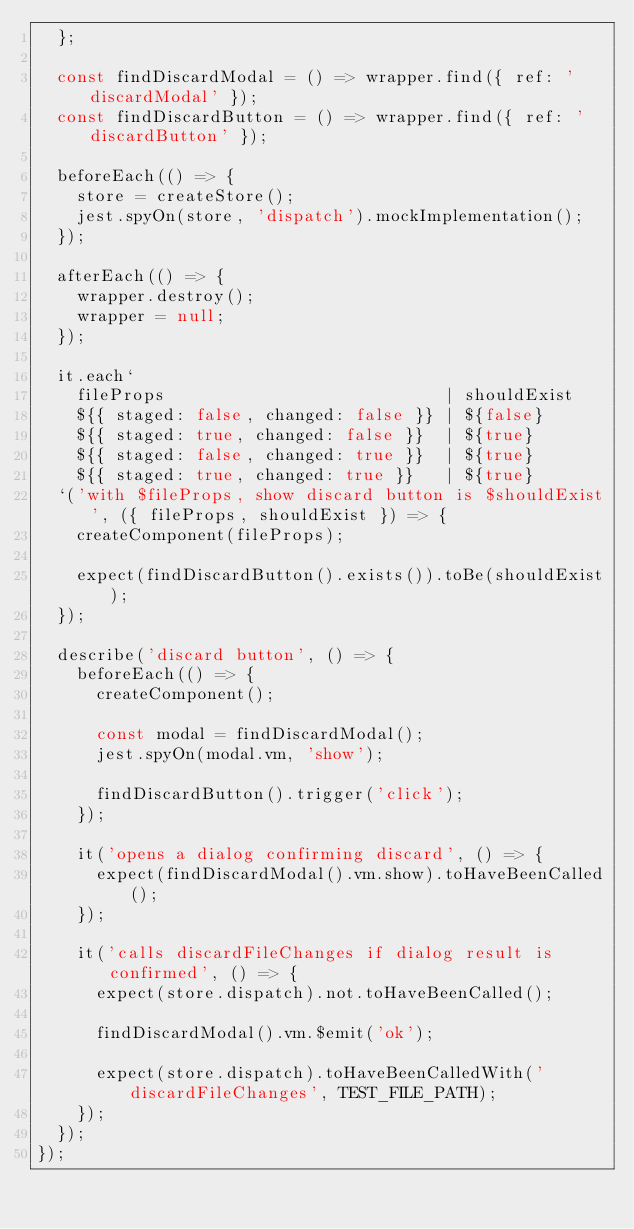Convert code to text. <code><loc_0><loc_0><loc_500><loc_500><_JavaScript_>  };

  const findDiscardModal = () => wrapper.find({ ref: 'discardModal' });
  const findDiscardButton = () => wrapper.find({ ref: 'discardButton' });

  beforeEach(() => {
    store = createStore();
    jest.spyOn(store, 'dispatch').mockImplementation();
  });

  afterEach(() => {
    wrapper.destroy();
    wrapper = null;
  });

  it.each`
    fileProps                            | shouldExist
    ${{ staged: false, changed: false }} | ${false}
    ${{ staged: true, changed: false }}  | ${true}
    ${{ staged: false, changed: true }}  | ${true}
    ${{ staged: true, changed: true }}   | ${true}
  `('with $fileProps, show discard button is $shouldExist', ({ fileProps, shouldExist }) => {
    createComponent(fileProps);

    expect(findDiscardButton().exists()).toBe(shouldExist);
  });

  describe('discard button', () => {
    beforeEach(() => {
      createComponent();

      const modal = findDiscardModal();
      jest.spyOn(modal.vm, 'show');

      findDiscardButton().trigger('click');
    });

    it('opens a dialog confirming discard', () => {
      expect(findDiscardModal().vm.show).toHaveBeenCalled();
    });

    it('calls discardFileChanges if dialog result is confirmed', () => {
      expect(store.dispatch).not.toHaveBeenCalled();

      findDiscardModal().vm.$emit('ok');

      expect(store.dispatch).toHaveBeenCalledWith('discardFileChanges', TEST_FILE_PATH);
    });
  });
});
</code> 